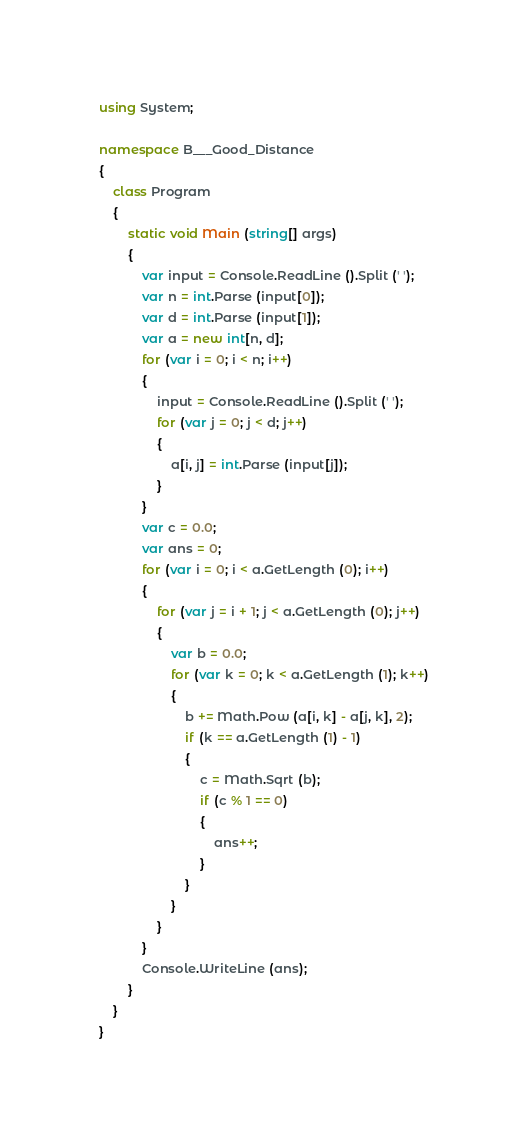<code> <loc_0><loc_0><loc_500><loc_500><_C#_>using System;

namespace B___Good_Distance
{
    class Program
    {
        static void Main (string[] args)
        {
            var input = Console.ReadLine ().Split (' ');
            var n = int.Parse (input[0]);
            var d = int.Parse (input[1]);
            var a = new int[n, d];
            for (var i = 0; i < n; i++)
            {
                input = Console.ReadLine ().Split (' ');
                for (var j = 0; j < d; j++)
                {
                    a[i, j] = int.Parse (input[j]);
                }
            }
            var c = 0.0;
            var ans = 0;
            for (var i = 0; i < a.GetLength (0); i++)
            {
                for (var j = i + 1; j < a.GetLength (0); j++)
                {
                    var b = 0.0;
                    for (var k = 0; k < a.GetLength (1); k++)
                    {
                        b += Math.Pow (a[i, k] - a[j, k], 2);
                        if (k == a.GetLength (1) - 1)
                        {
                            c = Math.Sqrt (b);
                            if (c % 1 == 0)
                            {
                                ans++;
                            }
                        }
                    }
                }
            }
            Console.WriteLine (ans);
        }
    }
}</code> 